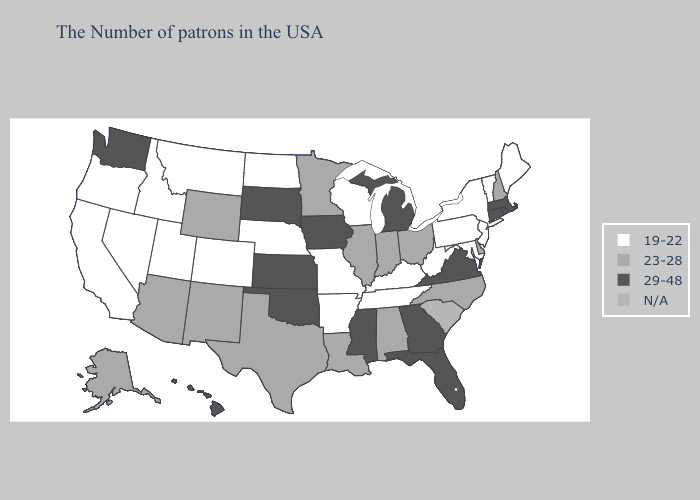Name the states that have a value in the range N/A?
Give a very brief answer. South Carolina. Does New Mexico have the lowest value in the USA?
Answer briefly. No. Name the states that have a value in the range N/A?
Be succinct. South Carolina. Name the states that have a value in the range 23-28?
Keep it brief. New Hampshire, Delaware, North Carolina, Ohio, Indiana, Alabama, Illinois, Louisiana, Minnesota, Texas, Wyoming, New Mexico, Arizona, Alaska. Name the states that have a value in the range 23-28?
Write a very short answer. New Hampshire, Delaware, North Carolina, Ohio, Indiana, Alabama, Illinois, Louisiana, Minnesota, Texas, Wyoming, New Mexico, Arizona, Alaska. What is the value of Ohio?
Write a very short answer. 23-28. Does Washington have the highest value in the West?
Write a very short answer. Yes. Name the states that have a value in the range N/A?
Concise answer only. South Carolina. Does the first symbol in the legend represent the smallest category?
Be succinct. Yes. What is the value of New Hampshire?
Answer briefly. 23-28. Name the states that have a value in the range 19-22?
Give a very brief answer. Maine, Vermont, New York, New Jersey, Maryland, Pennsylvania, West Virginia, Kentucky, Tennessee, Wisconsin, Missouri, Arkansas, Nebraska, North Dakota, Colorado, Utah, Montana, Idaho, Nevada, California, Oregon. What is the lowest value in states that border Oklahoma?
Write a very short answer. 19-22. 